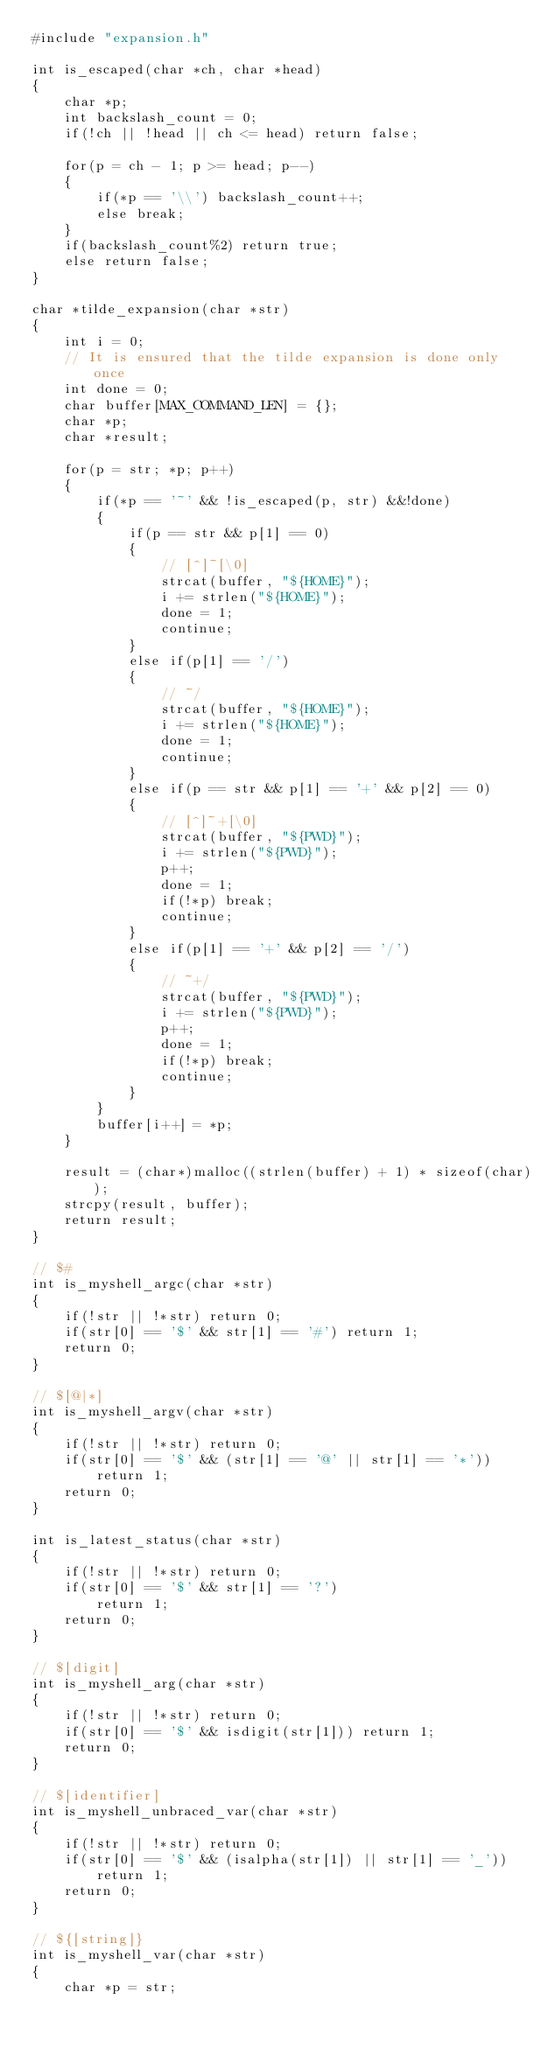Convert code to text. <code><loc_0><loc_0><loc_500><loc_500><_C_>#include "expansion.h"

int is_escaped(char *ch, char *head)
{
    char *p;
    int backslash_count = 0;
    if(!ch || !head || ch <= head) return false;
    
    for(p = ch - 1; p >= head; p--)
    {
        if(*p == '\\') backslash_count++;
        else break;
    }
    if(backslash_count%2) return true;
    else return false;
}

char *tilde_expansion(char *str)
{
    int i = 0;
    // It is ensured that the tilde expansion is done only once
    int done = 0;
    char buffer[MAX_COMMAND_LEN] = {};
    char *p;
    char *result;

    for(p = str; *p; p++)
    {
        if(*p == '~' && !is_escaped(p, str) &&!done)
        {
            if(p == str && p[1] == 0)
            {
                // [^]~[\0]
                strcat(buffer, "${HOME}");
                i += strlen("${HOME}");
                done = 1;
                continue;
            }
            else if(p[1] == '/')
            {
                // ~/
                strcat(buffer, "${HOME}");
                i += strlen("${HOME}");
                done = 1;
                continue;
            }
            else if(p == str && p[1] == '+' && p[2] == 0)
            {
                // [^]~+[\0]
                strcat(buffer, "${PWD}");
                i += strlen("${PWD}");
                p++;
                done = 1;
                if(!*p) break;
                continue;
            }
            else if(p[1] == '+' && p[2] == '/')
            {
                // ~+/
                strcat(buffer, "${PWD}");
                i += strlen("${PWD}");
                p++;
                done = 1;
                if(!*p) break;
                continue;
            }
        }
        buffer[i++] = *p;
    }

    result = (char*)malloc((strlen(buffer) + 1) * sizeof(char));
    strcpy(result, buffer);
    return result;
}

// $#
int is_myshell_argc(char *str)
{
    if(!str || !*str) return 0;
    if(str[0] == '$' && str[1] == '#') return 1;
    return 0;
}

// $[@|*]
int is_myshell_argv(char *str)
{
    if(!str || !*str) return 0;
    if(str[0] == '$' && (str[1] == '@' || str[1] == '*'))
        return 1;
    return 0;
}

int is_latest_status(char *str)
{
    if(!str || !*str) return 0;
    if(str[0] == '$' && str[1] == '?')
        return 1;
    return 0;
}

// $[digit]
int is_myshell_arg(char *str)
{
    if(!str || !*str) return 0;
    if(str[0] == '$' && isdigit(str[1])) return 1;
    return 0;
}

// $[identifier]
int is_myshell_unbraced_var(char *str)
{
    if(!str || !*str) return 0;
    if(str[0] == '$' && (isalpha(str[1]) || str[1] == '_'))
        return 1;
    return 0;
}

// ${[string]}
int is_myshell_var(char *str)
{
    char *p = str;</code> 